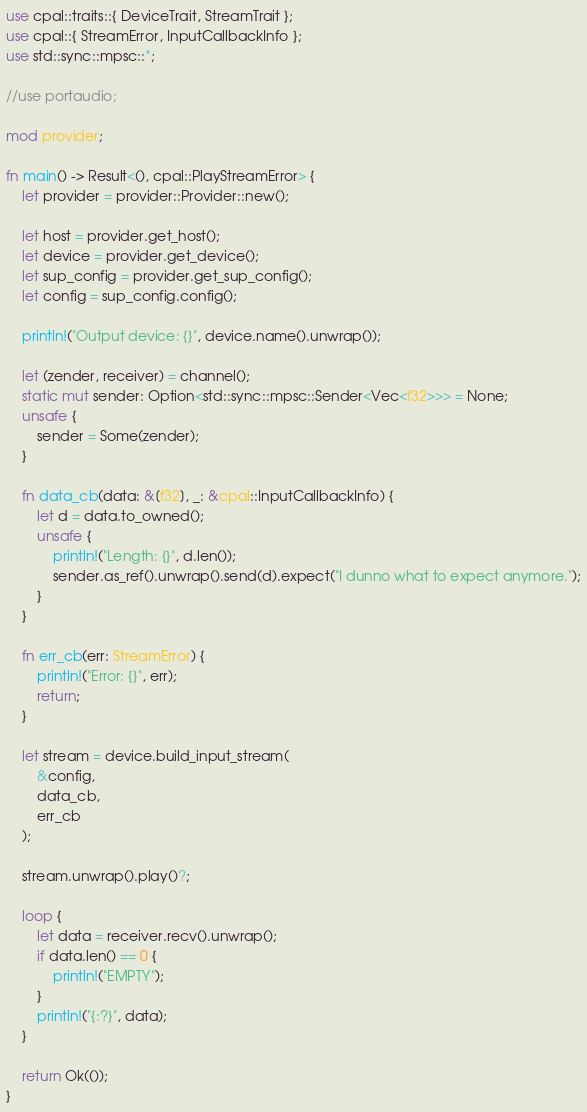<code> <loc_0><loc_0><loc_500><loc_500><_Rust_>use cpal::traits::{ DeviceTrait, StreamTrait };
use cpal::{ StreamError, InputCallbackInfo };
use std::sync::mpsc::*;

//use portaudio;

mod provider;

fn main() -> Result<(), cpal::PlayStreamError> {
    let provider = provider::Provider::new();

    let host = provider.get_host();
    let device = provider.get_device();
    let sup_config = provider.get_sup_config();
    let config = sup_config.config();

    println!("Output device: {}", device.name().unwrap());

    let (zender, receiver) = channel();
    static mut sender: Option<std::sync::mpsc::Sender<Vec<f32>>> = None;
    unsafe {
        sender = Some(zender);
    }

    fn data_cb(data: &[f32], _: &cpal::InputCallbackInfo) {
        let d = data.to_owned();
        unsafe {
            println!("Length: {}", d.len());
            sender.as_ref().unwrap().send(d).expect("I dunno what to expect anymore.");
        }
    }

    fn err_cb(err: StreamError) {
        println!("Error: {}", err);
        return;
    }

    let stream = device.build_input_stream(
        &config,
        data_cb,
        err_cb
    );

    stream.unwrap().play()?;

    loop {
        let data = receiver.recv().unwrap();
        if data.len() == 0 {
            println!("EMPTY");
        }
        println!("{:?}", data);
    }

    return Ok(());
}
</code> 